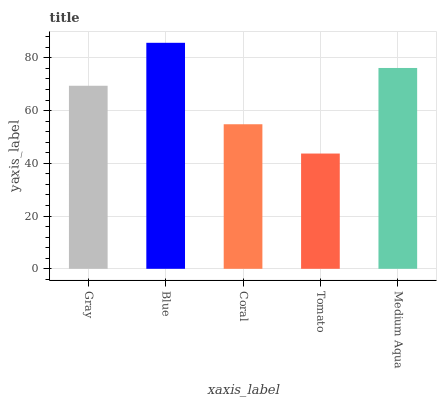Is Tomato the minimum?
Answer yes or no. Yes. Is Blue the maximum?
Answer yes or no. Yes. Is Coral the minimum?
Answer yes or no. No. Is Coral the maximum?
Answer yes or no. No. Is Blue greater than Coral?
Answer yes or no. Yes. Is Coral less than Blue?
Answer yes or no. Yes. Is Coral greater than Blue?
Answer yes or no. No. Is Blue less than Coral?
Answer yes or no. No. Is Gray the high median?
Answer yes or no. Yes. Is Gray the low median?
Answer yes or no. Yes. Is Medium Aqua the high median?
Answer yes or no. No. Is Coral the low median?
Answer yes or no. No. 